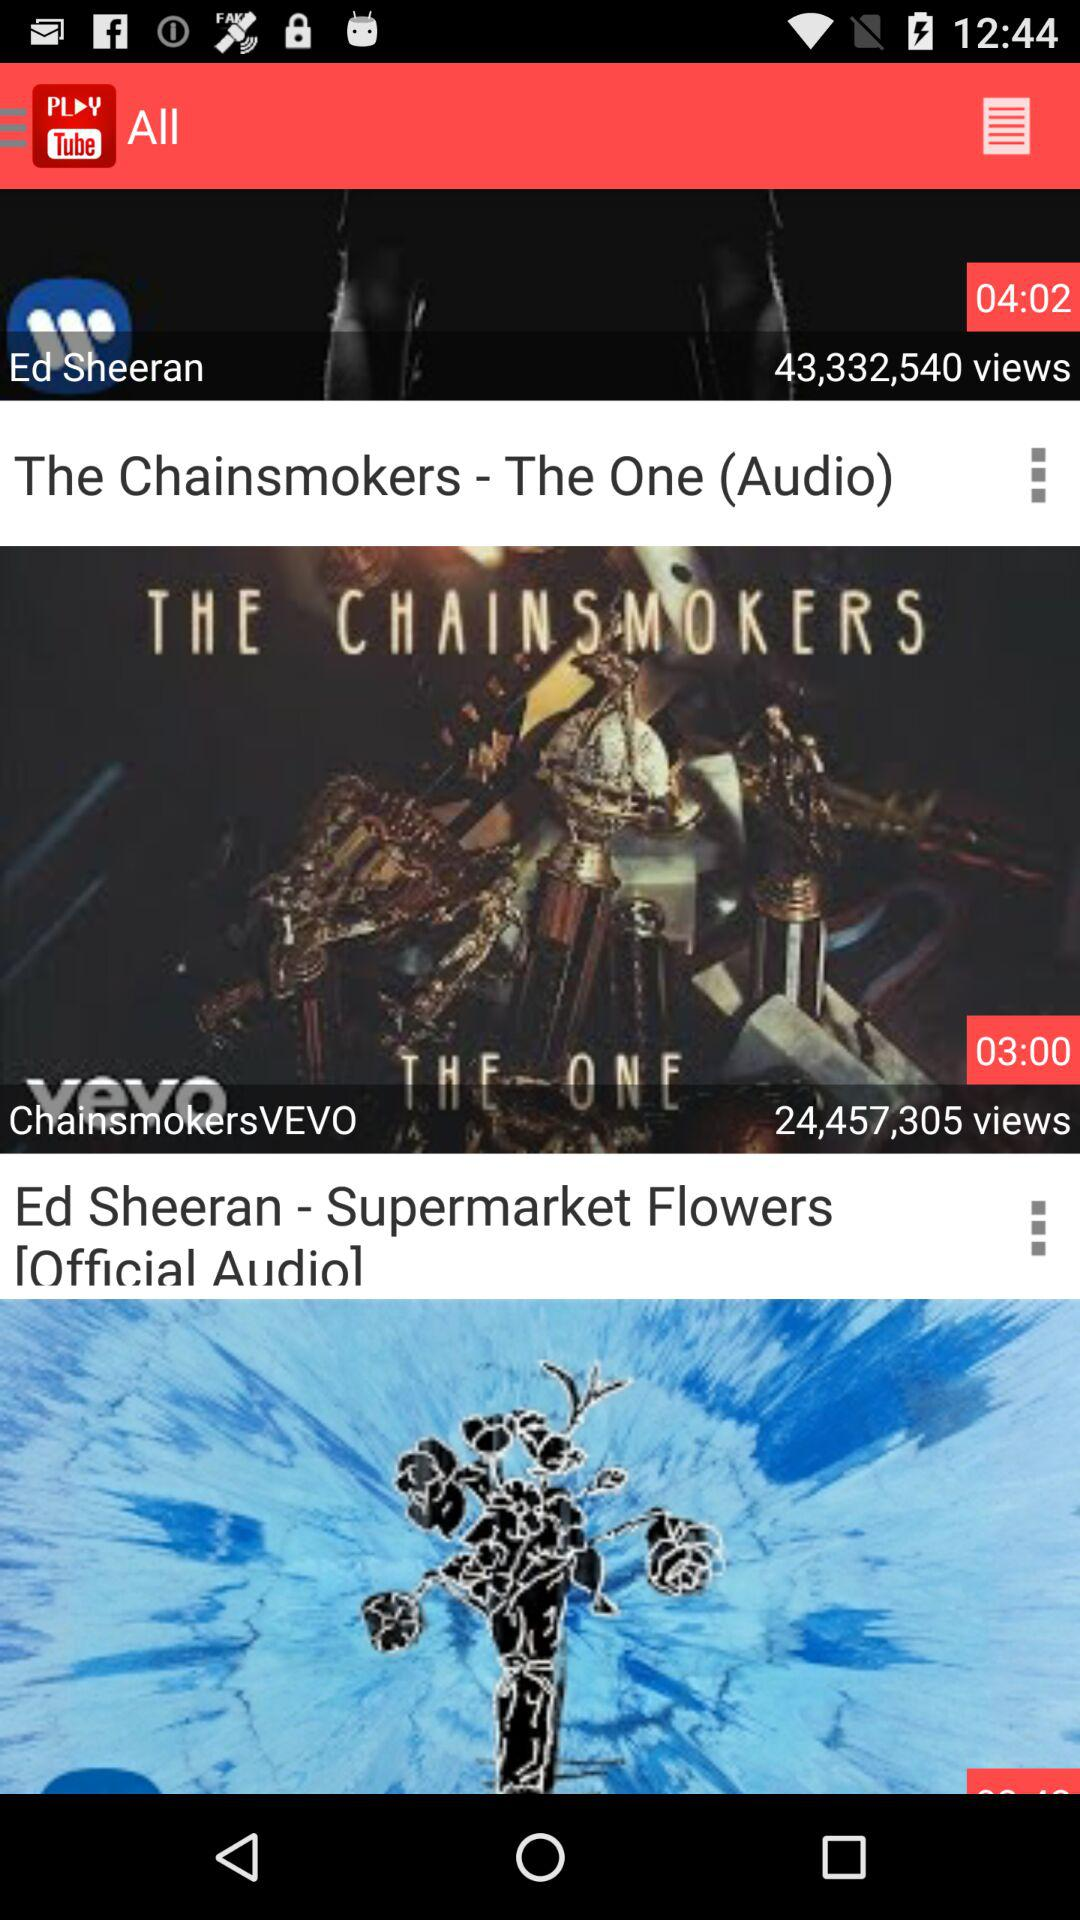What genres do these two videos represent? The first video appears to be a pop or electronic music track by The Chainsmokers, and the second video could be a pop or singer-songwriter track by Ed Sheeran. 